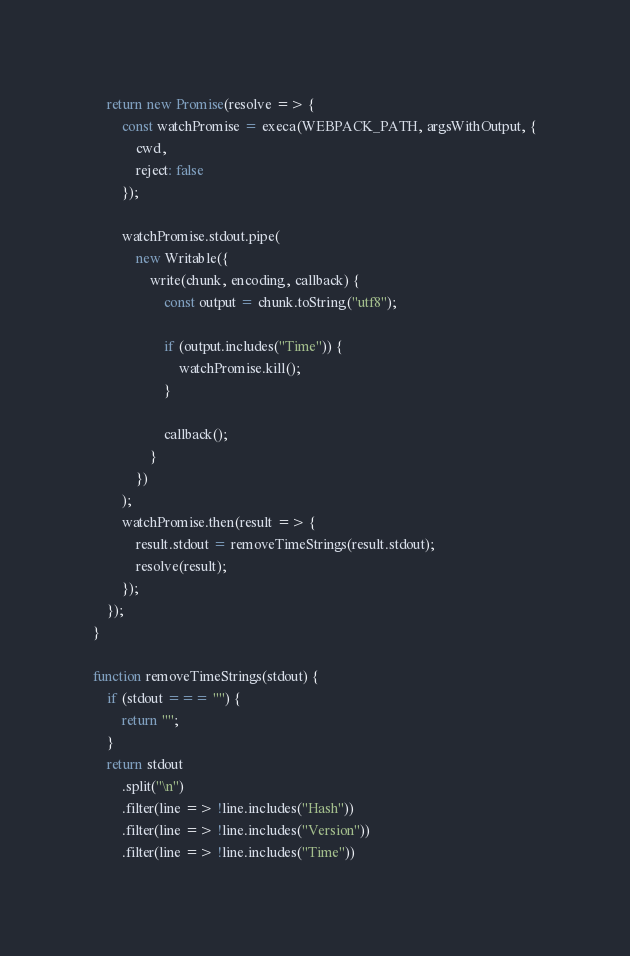Convert code to text. <code><loc_0><loc_0><loc_500><loc_500><_JavaScript_>
	return new Promise(resolve => {
		const watchPromise = execa(WEBPACK_PATH, argsWithOutput, {
			cwd,
			reject: false
		});

		watchPromise.stdout.pipe(
			new Writable({
				write(chunk, encoding, callback) {
					const output = chunk.toString("utf8");

					if (output.includes("Time")) {
						watchPromise.kill();
					}

					callback();
				}
			})
		);
		watchPromise.then(result => {
			result.stdout = removeTimeStrings(result.stdout);
			resolve(result);
		});
	});
}

function removeTimeStrings(stdout) {
	if (stdout === "") {
		return "";
	}
	return stdout
		.split("\n")
		.filter(line => !line.includes("Hash"))
		.filter(line => !line.includes("Version"))
		.filter(line => !line.includes("Time"))</code> 